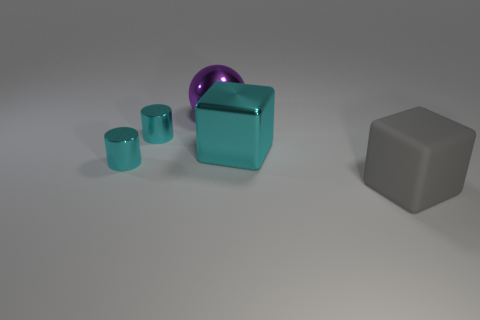Add 1 large blue blocks. How many objects exist? 6 Subtract all cylinders. How many objects are left? 3 Subtract all green metal cylinders. Subtract all metal things. How many objects are left? 1 Add 2 big things. How many big things are left? 5 Add 5 blocks. How many blocks exist? 7 Subtract 0 purple blocks. How many objects are left? 5 